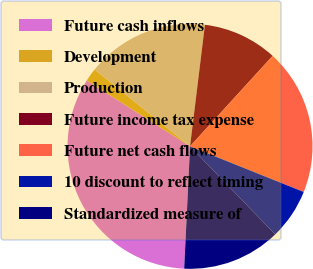<chart> <loc_0><loc_0><loc_500><loc_500><pie_chart><fcel>Future cash inflows<fcel>Development<fcel>Production<fcel>Future income tax expense<fcel>Future net cash flows<fcel>10 discount to reflect timing<fcel>Standardized measure of<nl><fcel>33.27%<fcel>1.76%<fcel>16.15%<fcel>9.84%<fcel>19.3%<fcel>6.69%<fcel>13.0%<nl></chart> 